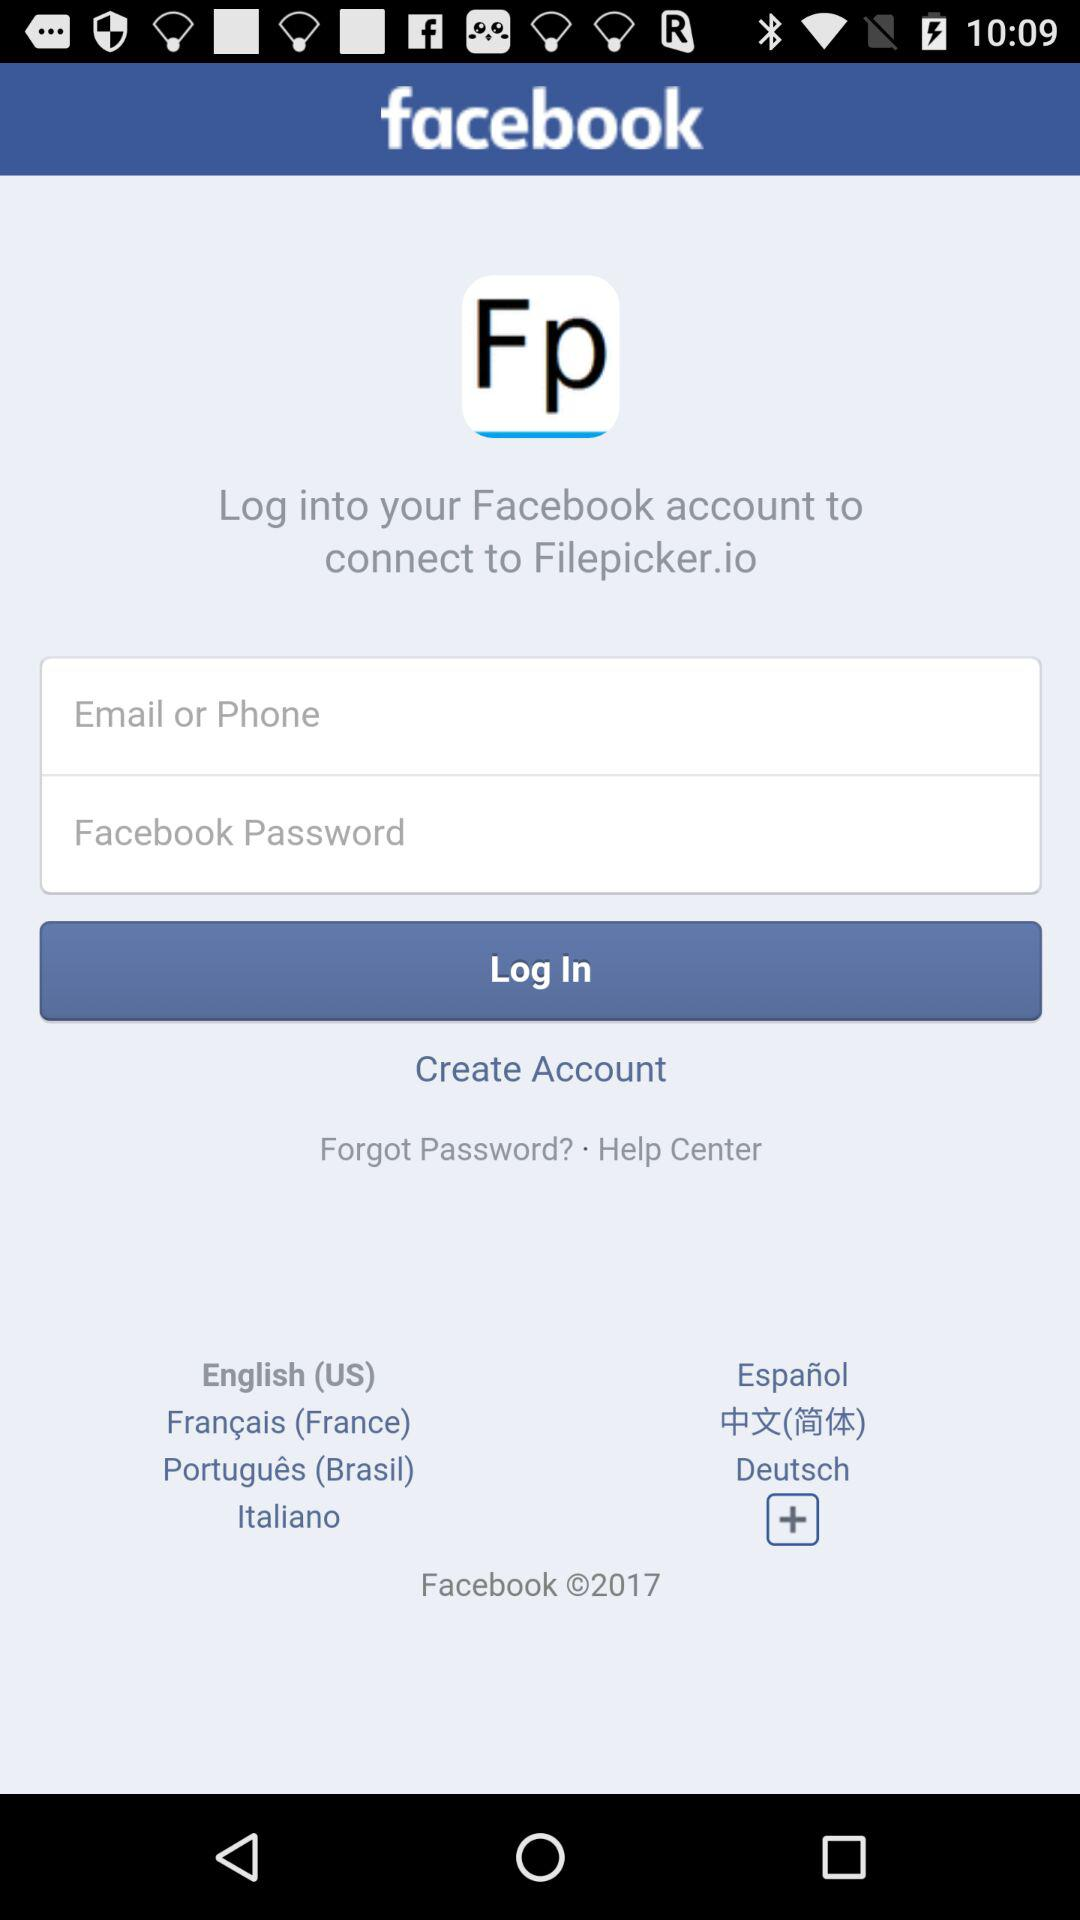Which's the application name? The application names are "Filepicker.io" and "facebook". 